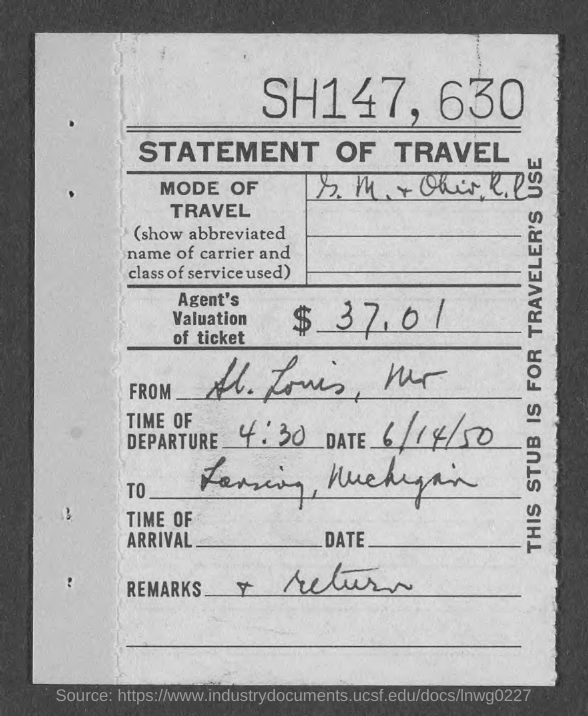What is the time of departure?
Give a very brief answer. 4:30. What is the date mentioned in the document?
Offer a terse response. 6/14/50. What is the amount?
Provide a short and direct response. $ 37,01. 